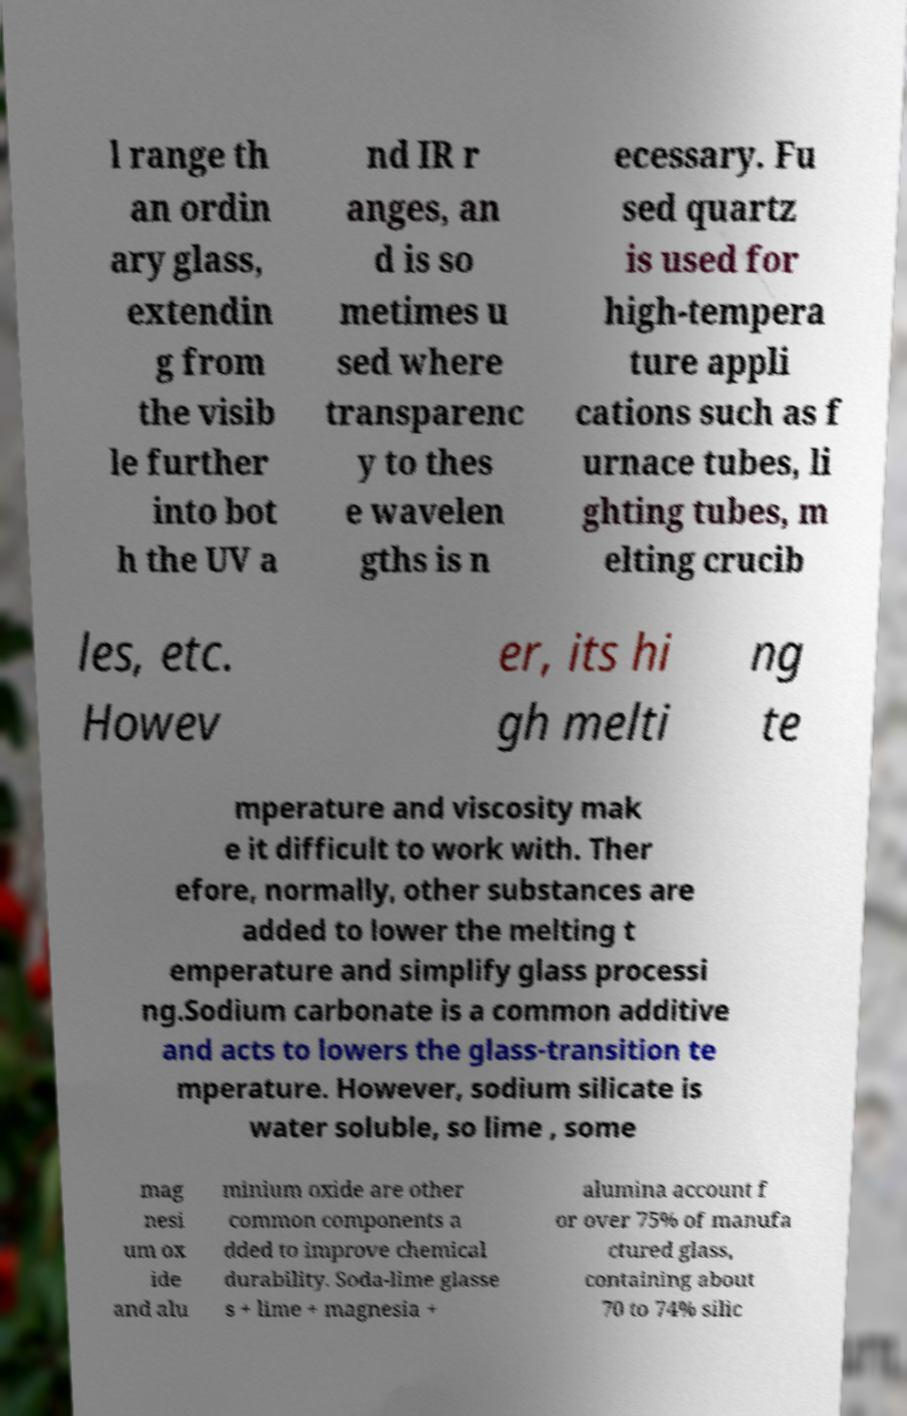Please identify and transcribe the text found in this image. l range th an ordin ary glass, extendin g from the visib le further into bot h the UV a nd IR r anges, an d is so metimes u sed where transparenc y to thes e wavelen gths is n ecessary. Fu sed quartz is used for high-tempera ture appli cations such as f urnace tubes, li ghting tubes, m elting crucib les, etc. Howev er, its hi gh melti ng te mperature and viscosity mak e it difficult to work with. Ther efore, normally, other substances are added to lower the melting t emperature and simplify glass processi ng.Sodium carbonate is a common additive and acts to lowers the glass-transition te mperature. However, sodium silicate is water soluble, so lime , some mag nesi um ox ide and alu minium oxide are other common components a dded to improve chemical durability. Soda-lime glasse s + lime + magnesia + alumina account f or over 75% of manufa ctured glass, containing about 70 to 74% silic 